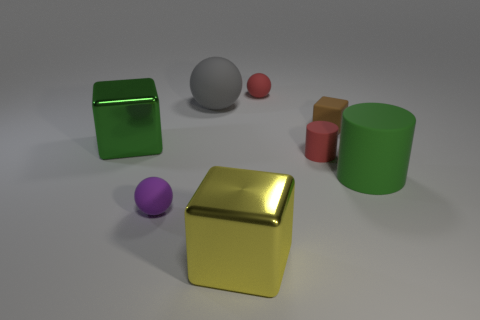Add 2 large green cubes. How many objects exist? 10 Subtract all spheres. How many objects are left? 5 Add 6 tiny yellow shiny things. How many tiny yellow shiny things exist? 6 Subtract 1 yellow blocks. How many objects are left? 7 Subtract all tiny blue matte cubes. Subtract all big gray things. How many objects are left? 7 Add 7 cylinders. How many cylinders are left? 9 